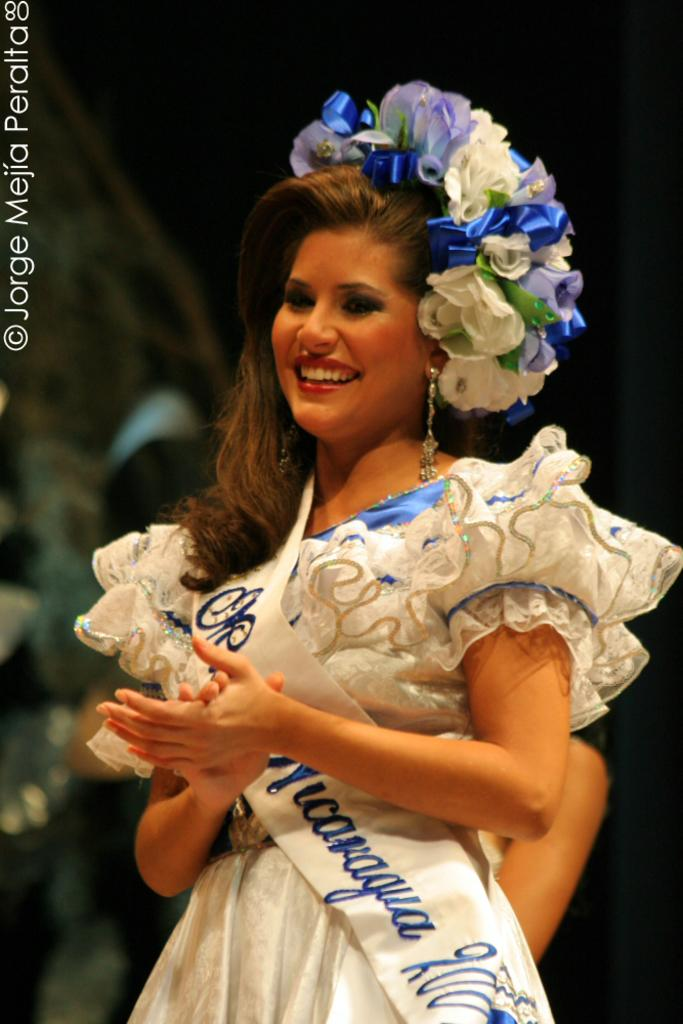<image>
Provide a brief description of the given image. A pageant winner with a sash saying Ms. Nicaragua on it. 